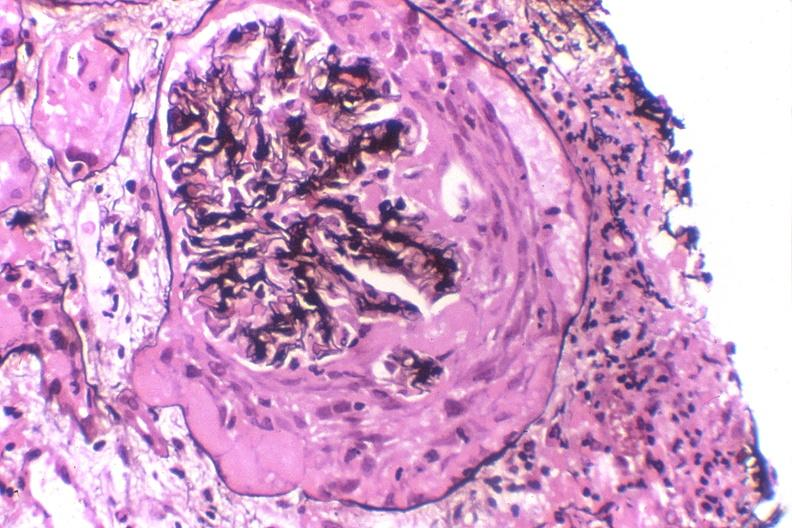does this image show crescentric glomerulonephritis?
Answer the question using a single word or phrase. Yes 